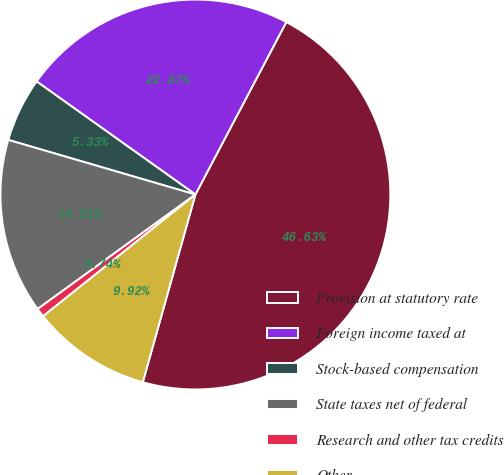Convert chart. <chart><loc_0><loc_0><loc_500><loc_500><pie_chart><fcel>Provision at statutory rate<fcel>Foreign income taxed at<fcel>Stock-based compensation<fcel>State taxes net of federal<fcel>Research and other tax credits<fcel>Other<nl><fcel>46.63%<fcel>22.87%<fcel>5.33%<fcel>14.51%<fcel>0.74%<fcel>9.92%<nl></chart> 